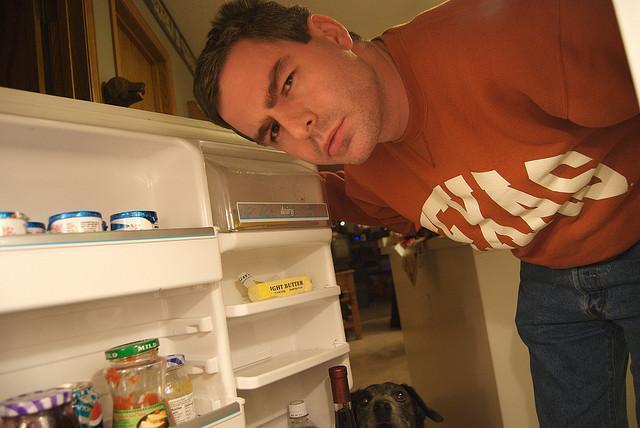How many refrigerators are in the photo?
Give a very brief answer. 1. How many people are there?
Give a very brief answer. 1. 